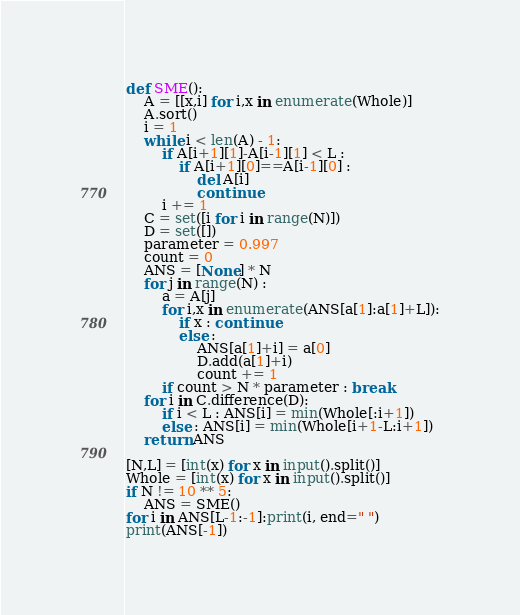Convert code to text. <code><loc_0><loc_0><loc_500><loc_500><_Python_>def SME():
    A = [[x,i] for i,x in enumerate(Whole)]
    A.sort()
    i = 1
    while i < len(A) - 1:
        if A[i+1][1]-A[i-1][1] < L :
            if A[i+1][0]==A[i-1][0] :
                del A[i]
                continue
        i += 1
    C = set([i for i in range(N)])
    D = set([])
    parameter = 0.997
    count = 0
    ANS = [None] * N
    for j in range(N) :
        a = A[j]
        for i,x in enumerate(ANS[a[1]:a[1]+L]):
            if x : continue
            else :
                ANS[a[1]+i] = a[0]
                D.add(a[1]+i)
                count += 1
        if count > N * parameter : break
    for i in C.difference(D):
        if i < L : ANS[i] = min(Whole[:i+1])
        else : ANS[i] = min(Whole[i+1-L:i+1])
    return ANS

[N,L] = [int(x) for x in input().split()]
Whole = [int(x) for x in input().split()]
if N != 10 ** 5:
    ANS = SME()
for i in ANS[L-1:-1]:print(i, end=" ")
print(ANS[-1])</code> 